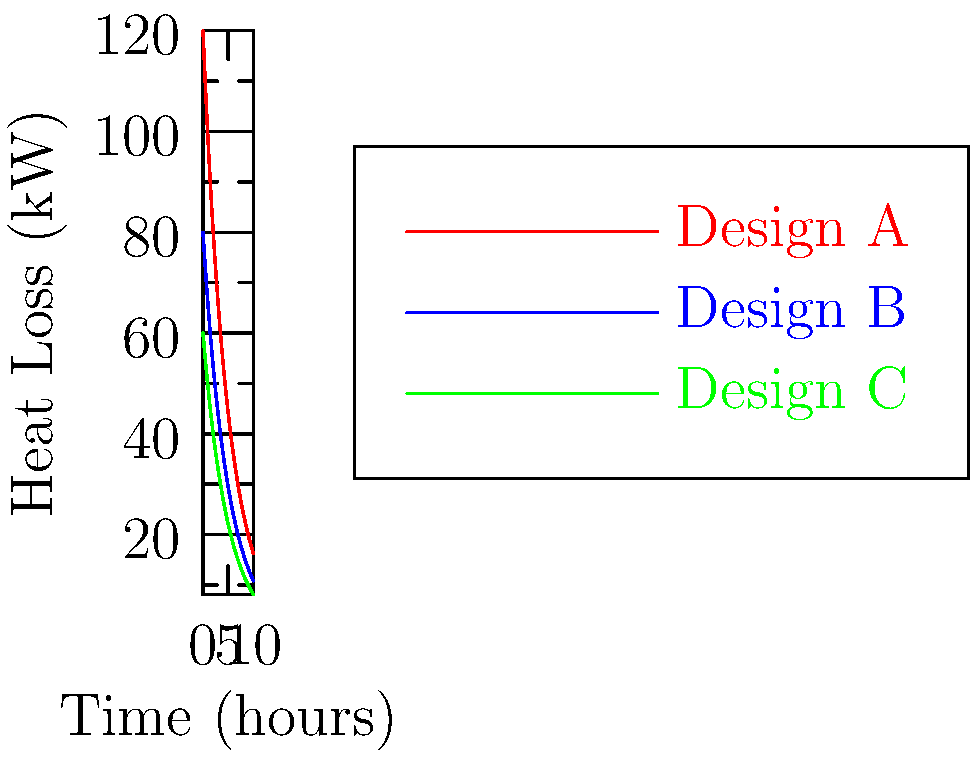As a university administrator overseeing the construction of a new engineering building, you're presented with heat loss diagrams for three different building designs. The graph shows heat loss over time for Designs A, B, and C. Which design would you recommend to maximize energy efficiency and minimize long-term operational costs? To determine the most energy-efficient design, we need to analyze the heat loss characteristics of each design:

1. Interpret the graph:
   - The y-axis represents heat loss in kilowatts (kW)
   - The x-axis represents time in hours
   - Each curve represents a different building design

2. Compare initial heat loss (t = 0):
   - Design A: ~120 kW
   - Design B: ~80 kW
   - Design C: ~60 kW

3. Observe the rate of heat loss decrease:
   - All designs follow an exponential decay curve
   - Design C has the lowest starting point and maintains the lowest heat loss throughout

4. Consider long-term performance:
   - After 10 hours, Design C still shows the lowest heat loss

5. Implications for energy efficiency:
   - Lower heat loss means less energy required for heating
   - Consistent lower heat loss translates to long-term energy savings

6. Cost considerations:
   - Lower energy consumption leads to reduced operational costs
   - Initial construction costs are not provided, but long-term savings often outweigh higher upfront costs for efficient designs

Based on this analysis, Design C demonstrates the best energy efficiency characteristics, with the lowest initial and sustained heat loss over time.
Answer: Design C 